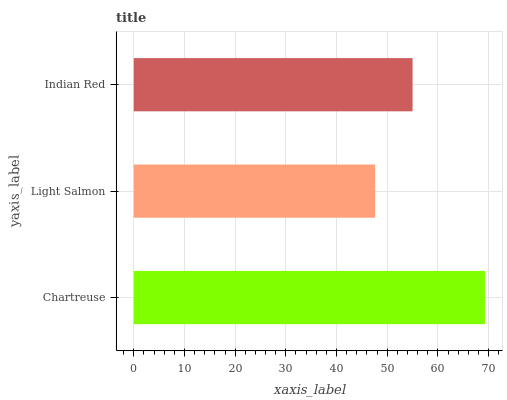Is Light Salmon the minimum?
Answer yes or no. Yes. Is Chartreuse the maximum?
Answer yes or no. Yes. Is Indian Red the minimum?
Answer yes or no. No. Is Indian Red the maximum?
Answer yes or no. No. Is Indian Red greater than Light Salmon?
Answer yes or no. Yes. Is Light Salmon less than Indian Red?
Answer yes or no. Yes. Is Light Salmon greater than Indian Red?
Answer yes or no. No. Is Indian Red less than Light Salmon?
Answer yes or no. No. Is Indian Red the high median?
Answer yes or no. Yes. Is Indian Red the low median?
Answer yes or no. Yes. Is Chartreuse the high median?
Answer yes or no. No. Is Chartreuse the low median?
Answer yes or no. No. 